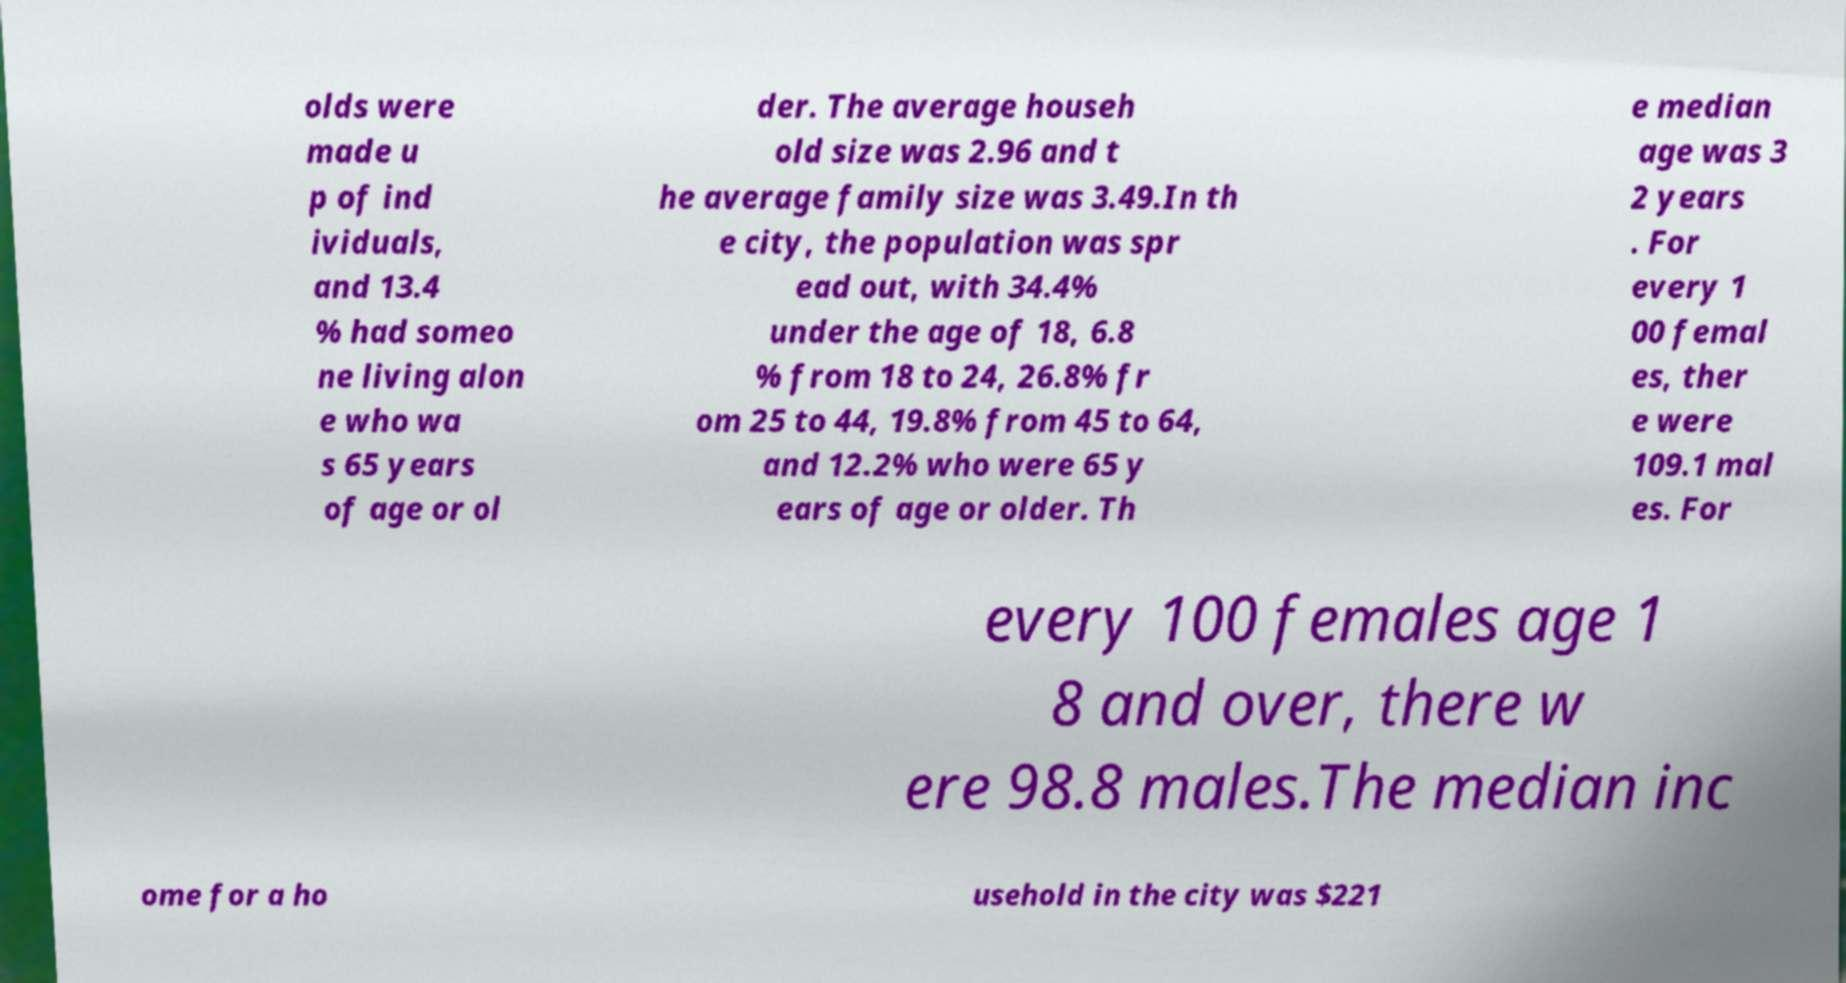Please read and relay the text visible in this image. What does it say? olds were made u p of ind ividuals, and 13.4 % had someo ne living alon e who wa s 65 years of age or ol der. The average househ old size was 2.96 and t he average family size was 3.49.In th e city, the population was spr ead out, with 34.4% under the age of 18, 6.8 % from 18 to 24, 26.8% fr om 25 to 44, 19.8% from 45 to 64, and 12.2% who were 65 y ears of age or older. Th e median age was 3 2 years . For every 1 00 femal es, ther e were 109.1 mal es. For every 100 females age 1 8 and over, there w ere 98.8 males.The median inc ome for a ho usehold in the city was $221 